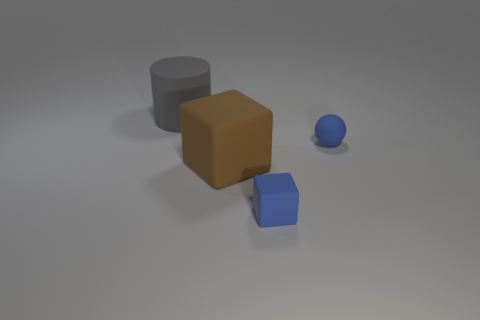Are there any gray cylinders that have the same size as the brown block?
Your answer should be compact. Yes. Is the number of large brown cubes greater than the number of tiny matte things?
Your answer should be compact. No. Does the blue object behind the blue matte block have the same size as the block that is left of the tiny blue rubber cube?
Provide a short and direct response. No. What number of matte objects are behind the brown matte thing and to the right of the brown block?
Offer a terse response. 1. There is a small thing that is the same shape as the big brown thing; what is its color?
Provide a succinct answer. Blue. Is the number of large objects less than the number of objects?
Provide a short and direct response. Yes. There is a gray object; is it the same size as the blue matte object behind the small blue cube?
Ensure brevity in your answer.  No. The rubber cube behind the matte block on the right side of the big matte block is what color?
Your answer should be very brief. Brown. How many objects are either rubber objects right of the big cylinder or large things on the right side of the gray cylinder?
Make the answer very short. 3. Do the blue ball and the brown object have the same size?
Ensure brevity in your answer.  No. 